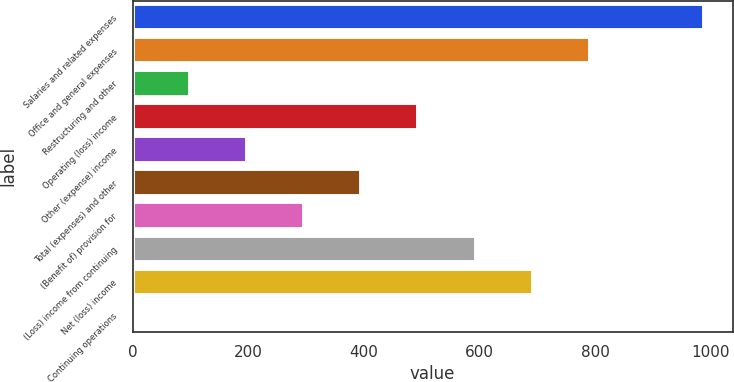<chart> <loc_0><loc_0><loc_500><loc_500><bar_chart><fcel>Salaries and related expenses<fcel>Office and general expenses<fcel>Restructuring and other<fcel>Operating (loss) income<fcel>Other (expense) income<fcel>Total (expenses) and other<fcel>(Benefit of) provision for<fcel>(Loss) income from continuing<fcel>Net (loss) income<fcel>Continuing operations<nl><fcel>988.8<fcel>791.09<fcel>99.14<fcel>494.54<fcel>197.99<fcel>395.69<fcel>296.84<fcel>593.39<fcel>692.24<fcel>0.29<nl></chart> 